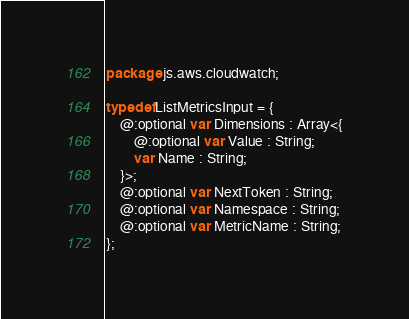<code> <loc_0><loc_0><loc_500><loc_500><_Haxe_>package js.aws.cloudwatch;

typedef ListMetricsInput = {
    @:optional var Dimensions : Array<{
        @:optional var Value : String;
        var Name : String;
    }>;
    @:optional var NextToken : String;
    @:optional var Namespace : String;
    @:optional var MetricName : String;
};
</code> 